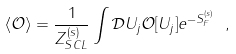<formula> <loc_0><loc_0><loc_500><loc_500>\left \langle \mathcal { O } \right \rangle = \frac { 1 } { Z _ { S C L } ^ { ( s ) } } \int \mathcal { D } U _ { j } \mathcal { O } [ U _ { j } ] e ^ { - S _ { F } ^ { ( s ) } } \ ,</formula> 